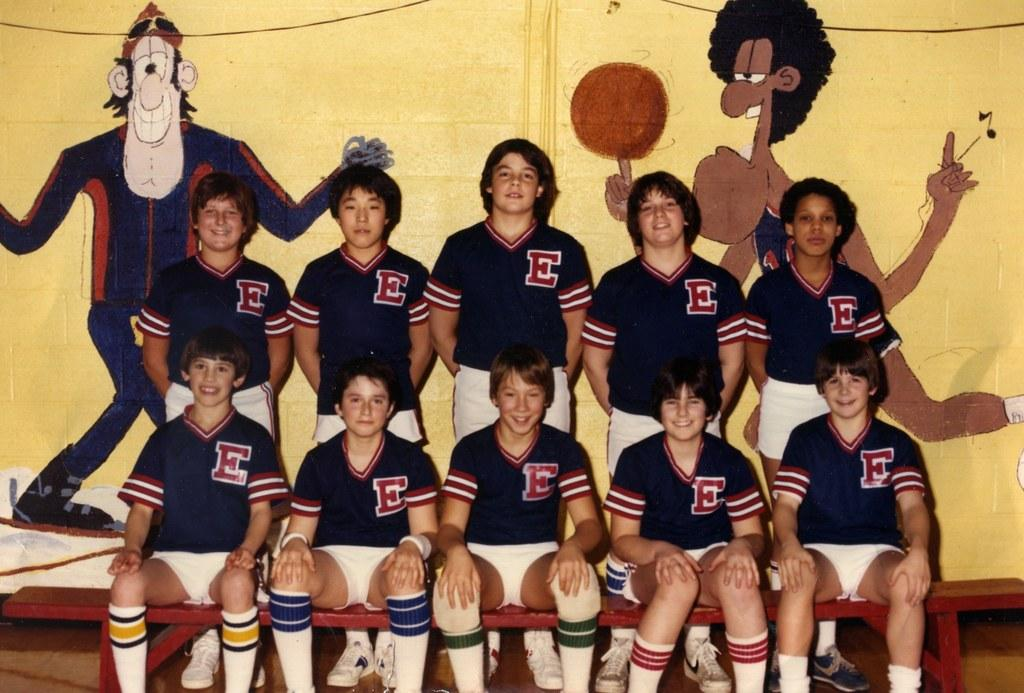<image>
Offer a succinct explanation of the picture presented. a group of players posing with the letter E on their jerseys 